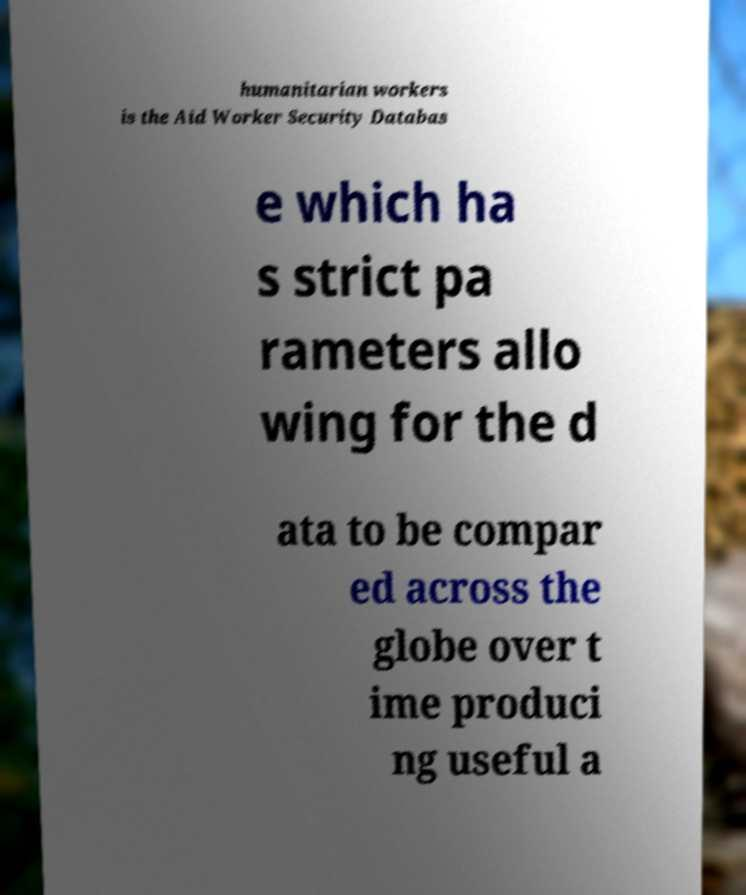Could you assist in decoding the text presented in this image and type it out clearly? humanitarian workers is the Aid Worker Security Databas e which ha s strict pa rameters allo wing for the d ata to be compar ed across the globe over t ime produci ng useful a 